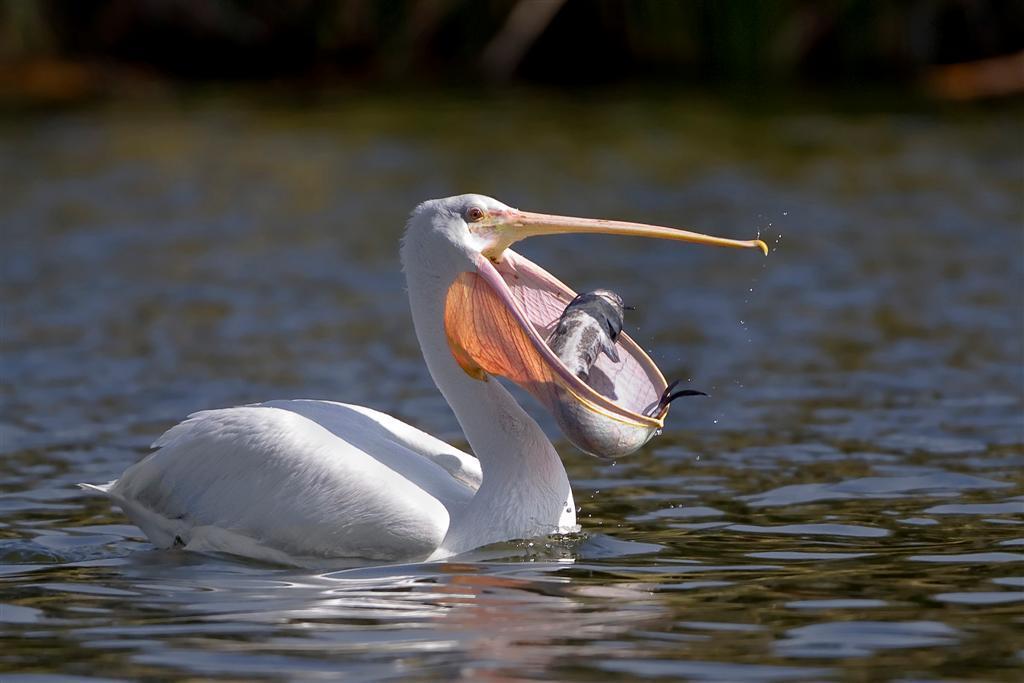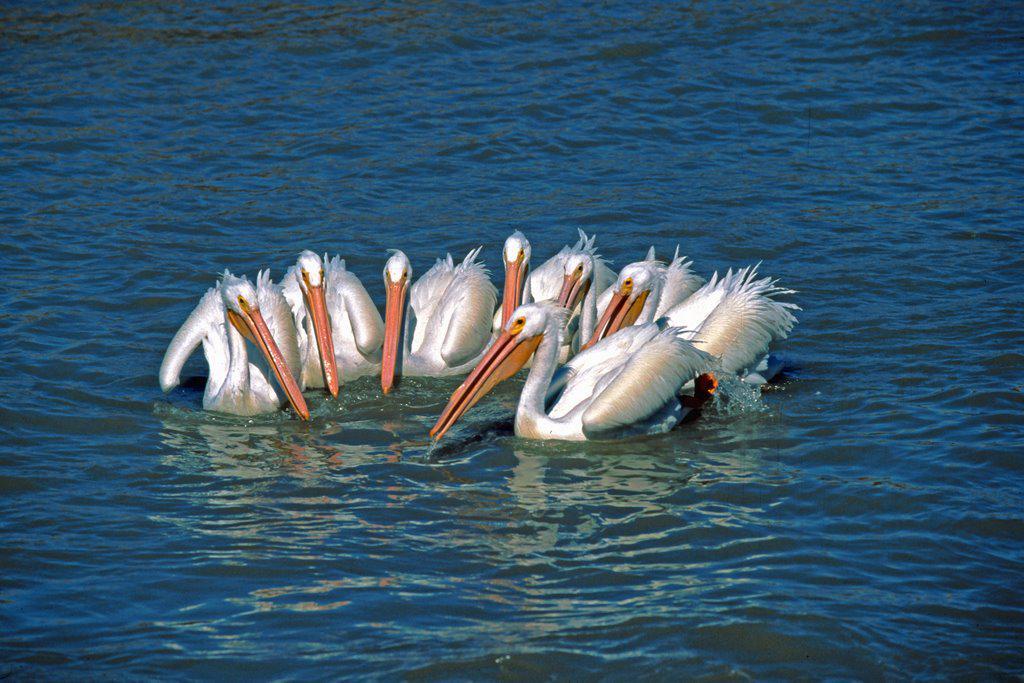The first image is the image on the left, the second image is the image on the right. For the images shown, is this caption "The bird on the left has a fish, but there are no fish in the right image." true? Answer yes or no. Yes. 